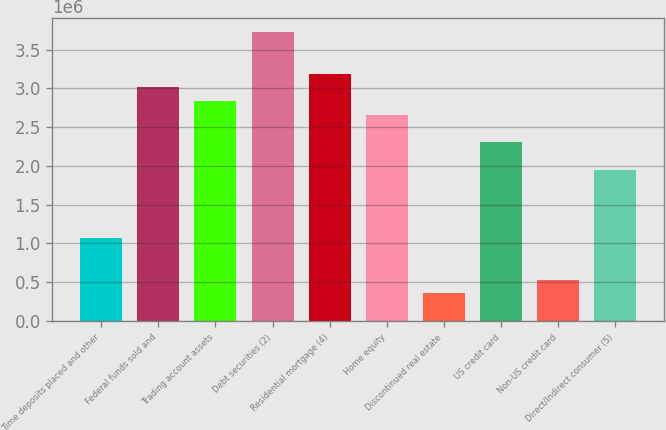Convert chart. <chart><loc_0><loc_0><loc_500><loc_500><bar_chart><fcel>Time deposits placed and other<fcel>Federal funds sold and<fcel>Trading account assets<fcel>Debt securities (2)<fcel>Residential mortgage (4)<fcel>Home equity<fcel>Discontinued real estate<fcel>US credit card<fcel>Non-US credit card<fcel>Direct/Indirect consumer (5)<nl><fcel>1.0639e+06<fcel>3.01274e+06<fcel>2.83557e+06<fcel>3.72141e+06<fcel>3.18991e+06<fcel>2.6584e+06<fcel>355230<fcel>2.30407e+06<fcel>532397<fcel>1.94974e+06<nl></chart> 